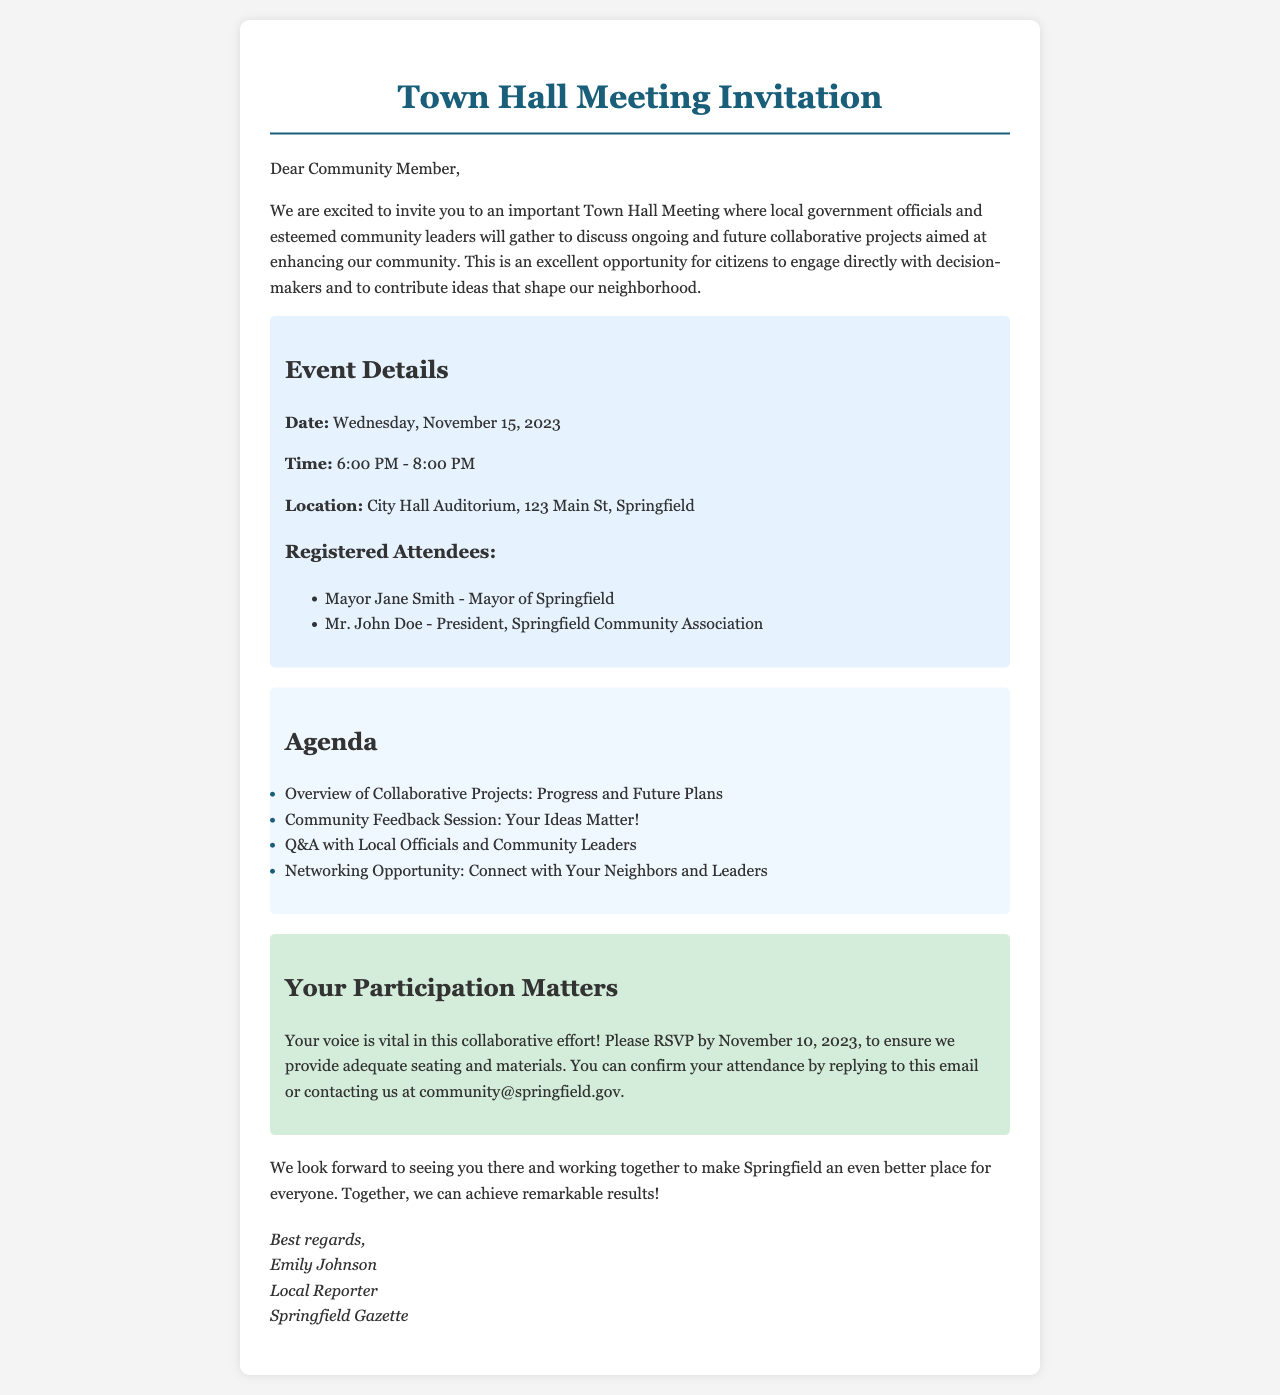What is the date of the Town Hall Meeting? The date is explicitly stated in the document as "Wednesday, November 15, 2023."
Answer: Wednesday, November 15, 2023 Who is the Mayor of Springfield? The document identifies the Mayor of Springfield as "Mayor Jane Smith."
Answer: Mayor Jane Smith During what hours will the Town Hall Meeting take place? The time of the event is listed as "6:00 PM - 8:00 PM."
Answer: 6:00 PM - 8:00 PM What is the purpose of the Town Hall Meeting? The document states the purpose is to discuss "ongoing and future collaborative projects aimed at enhancing our community."
Answer: Ongoing and future collaborative projects What should attendees do to confirm their attendance? The document specifies that attendees can confirm their attendance by "replying to this email or contacting us at community@springfield.gov."
Answer: Replying to this email or contacting us What is one item listed in the agenda for the meeting? The agenda contains several items, one of which is "Community Feedback Session: Your Ideas Matter!"
Answer: Community Feedback Session: Your Ideas Matter! What is the RSVP deadline for the meeting? The deadline to confirm attendance is "November 10, 2023."
Answer: November 10, 2023 What is the venue for the Town Hall Meeting? The location is mentioned as "City Hall Auditorium, 123 Main St, Springfield."
Answer: City Hall Auditorium, 123 Main St, Springfield 